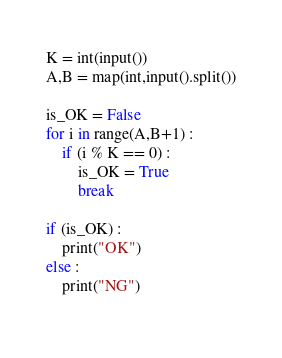<code> <loc_0><loc_0><loc_500><loc_500><_Python_>K = int(input())
A,B = map(int,input().split())

is_OK = False
for i in range(A,B+1) :
    if (i % K == 0) :
        is_OK = True
        break

if (is_OK) :
    print("OK")
else :
    print("NG")
        </code> 